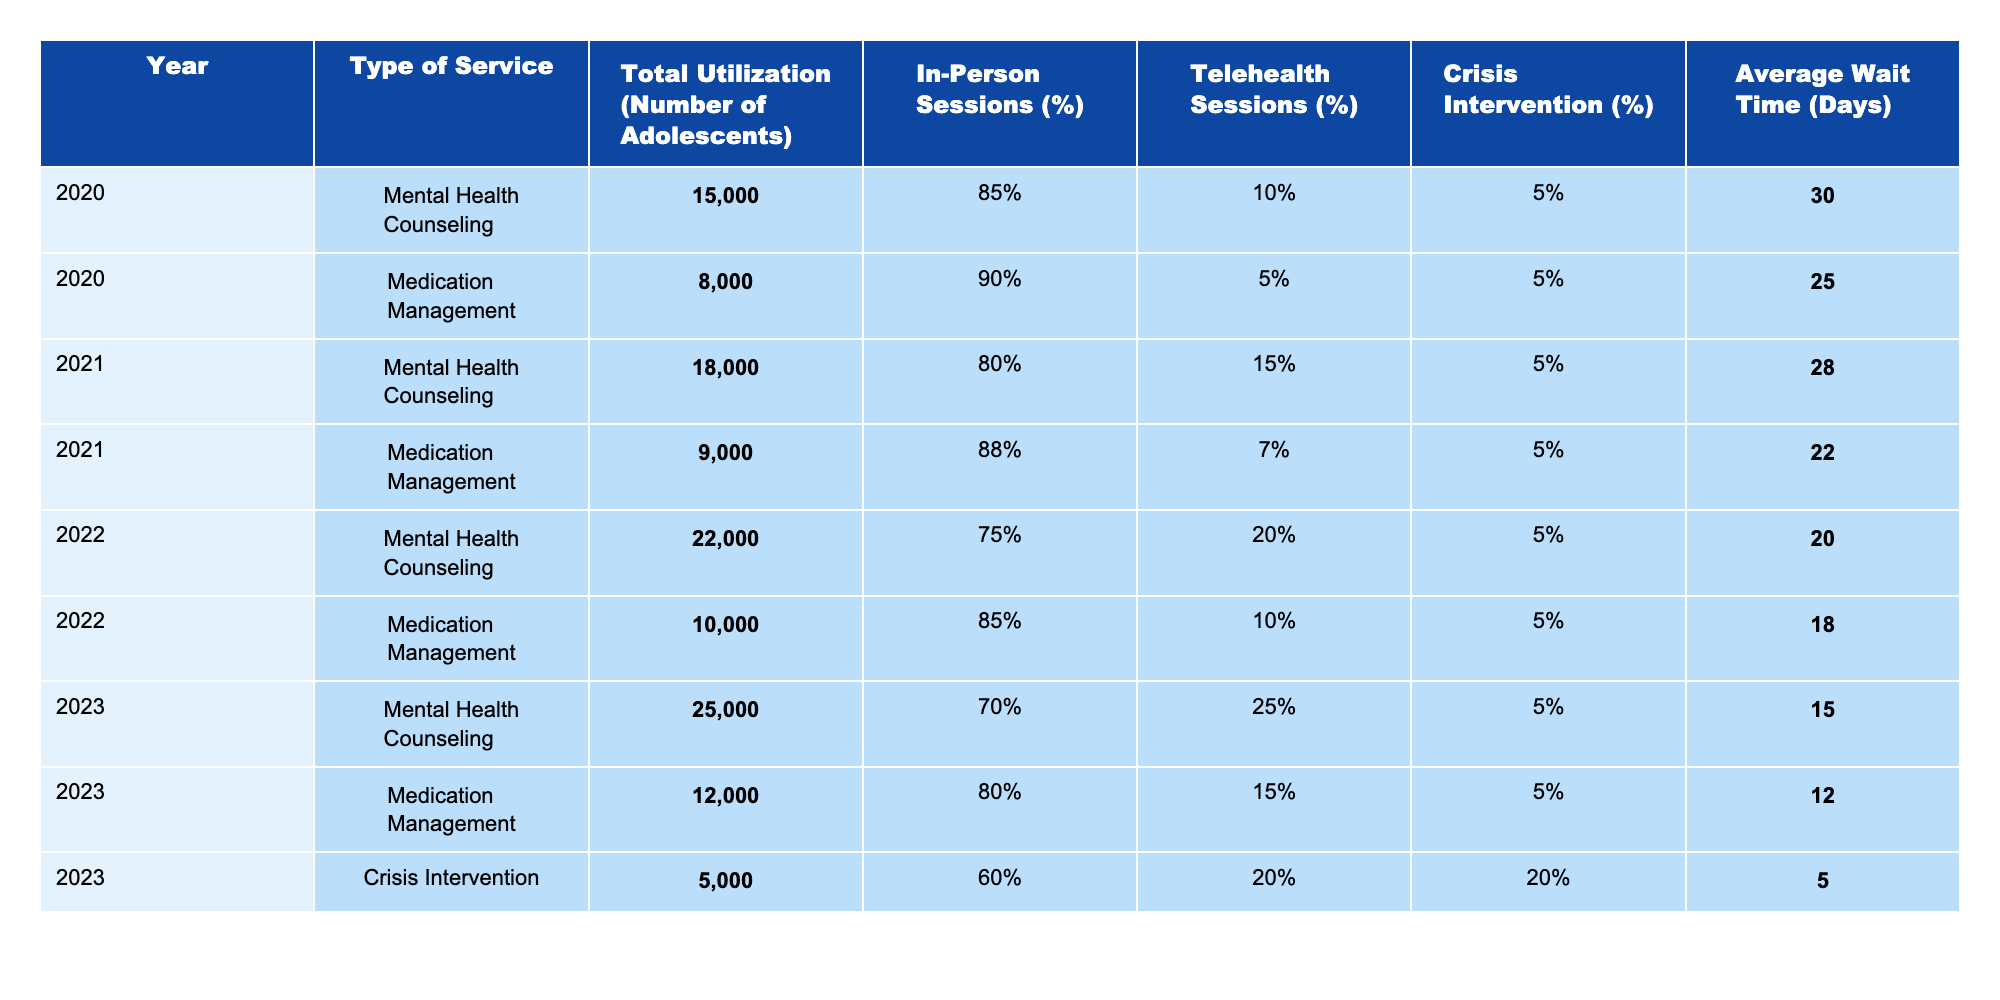What was the total utilization of Mental Health Counseling in 2023? In 2023, the table shows that the total utilization for Mental Health Counseling is listed as **25,000** adolescents.
Answer: 25,000 What percentage of Mental Health Counseling sessions were conducted in-person in 2022? The table indicates that in 2022, **75%** of Mental Health Counseling sessions were in-person.
Answer: 75% Is the average wait time for Medication Management shorter in 2023 than in 2020? In 2020, the average wait time for Medication Management is **25 days**, while in 2023 it is **12 days**. Since 12 days is less than 25 days, the answer is yes.
Answer: Yes What is the difference in total utilization of Medication Management between 2020 and 2023? The total utilization for Medication Management was **8,000** in 2020 and **12,000** in 2023. The difference is calculated as 12,000 - 8,000 = **4,000**.
Answer: 4,000 How has the percentage of telehealth sessions for Mental Health Counseling changed from 2021 to 2023? In 2021, the percentage of telehealth sessions was **15%** and in 2023 it rose to **25%**. The change is 25% - 15% = **10% increase**.
Answer: 10% increase What was the average wait time for Crisis Intervention services in 2023? The table shows that the average wait time for Crisis Intervention services in 2023 is **5 days**.
Answer: 5 days Did the total utilization of all types of services increase from 2020 to 2023? Adding the total utilizations: In 2020 total = 15,000 (Counseling) + 8,000 (Medication) = 23,000; In 2023 total = 25,000 (Counseling) + 12,000 (Medication) + 5,000 (Crisis) = 42,000. Since 42,000 > 23,000, the total utilization indeed increased.
Answer: Yes What is the average wait time across all service types for 2022? In 2022, the average wait times are 20 days (Counseling) and 18 days (Medication). To calculate the average: (20 + 18)/2 = 19 days.
Answer: 19 days Which type of service had the highest total utilization in any year from 2020 to 2023? Reviewing the total utilization figures, in 2023, Mental Health Counseling had the highest total utilization with **25,000** adolescents.
Answer: 25,000 Has the percentage of in-person sessions for Medication Management decreased from 2020 to 2023? In 2020, the in-person sessions for Medication Management were **90%**, and in 2023 they are **80%**. Since 80% is less than 90%, the answer is yes.
Answer: Yes 